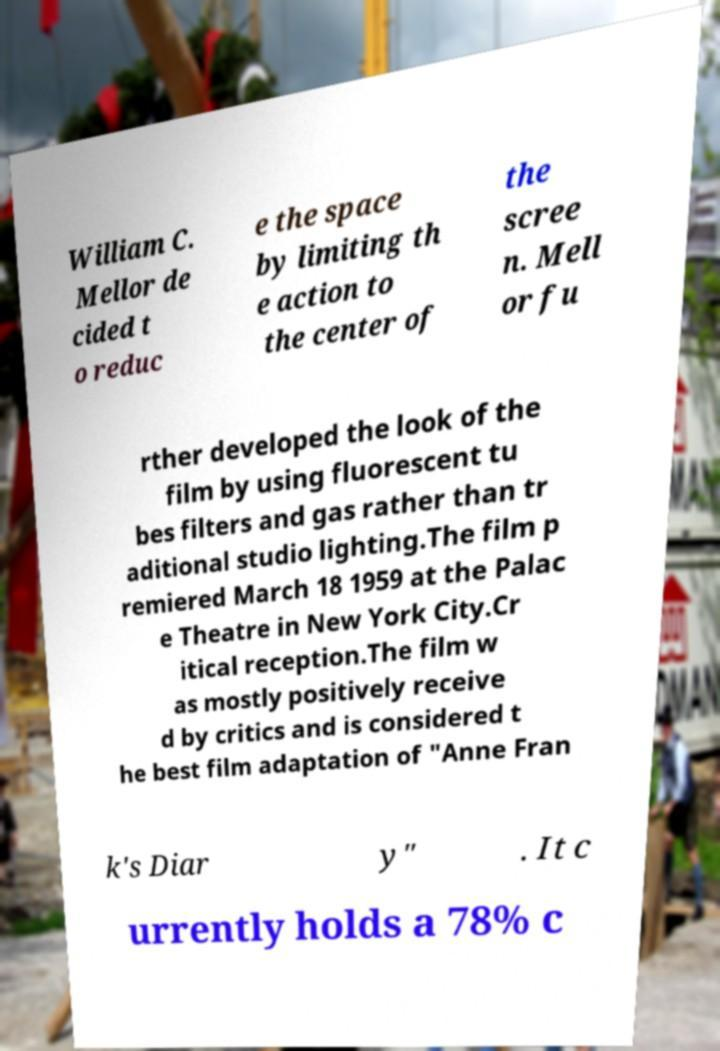Can you read and provide the text displayed in the image?This photo seems to have some interesting text. Can you extract and type it out for me? William C. Mellor de cided t o reduc e the space by limiting th e action to the center of the scree n. Mell or fu rther developed the look of the film by using fluorescent tu bes filters and gas rather than tr aditional studio lighting.The film p remiered March 18 1959 at the Palac e Theatre in New York City.Cr itical reception.The film w as mostly positively receive d by critics and is considered t he best film adaptation of "Anne Fran k's Diar y" . It c urrently holds a 78% c 